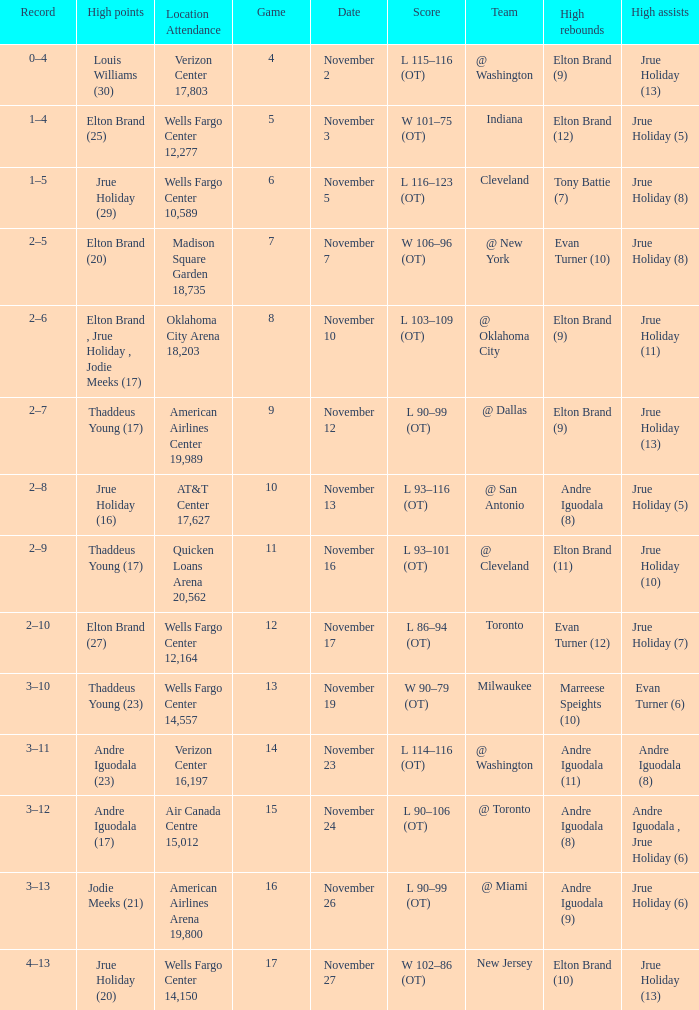What is the game number for the game with a score of l 90–106 (ot)? 15.0. 